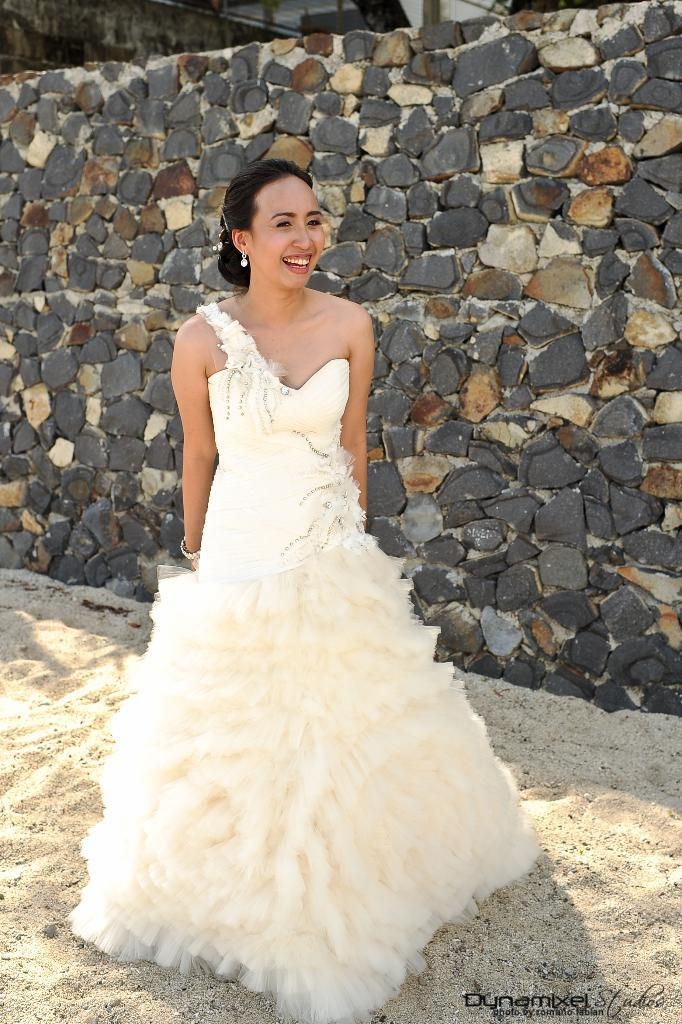Who is present in the image? There is a woman in the image. What is the woman standing on? The woman is standing on a sand surface. What is the woman wearing? The woman is wearing a white dress. What can be seen in the background of the image? There is a stone wall in the background of the image. What type of crook is the woman holding in the image? There is no crook present in the image. Is the woman a fireman in the image? The woman is not depicted as a fireman in the image. 